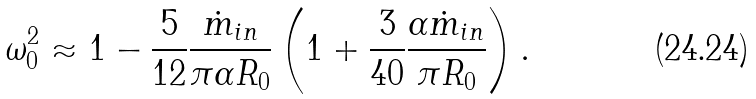<formula> <loc_0><loc_0><loc_500><loc_500>\omega _ { 0 } ^ { 2 } \approx 1 - \frac { 5 } { 1 2 } \frac { \dot { m } _ { i n } } { \pi \alpha R _ { 0 } } \left ( 1 + \frac { 3 } { 4 0 } \frac { \alpha \dot { m } _ { i n } } { \pi R _ { 0 } } \right ) .</formula> 